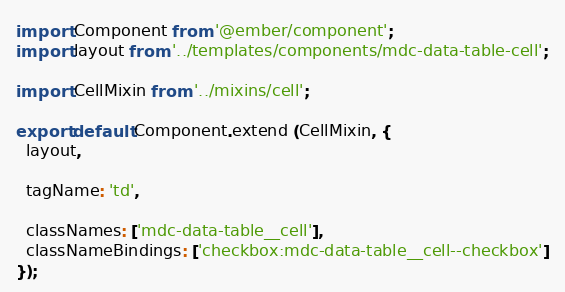Convert code to text. <code><loc_0><loc_0><loc_500><loc_500><_JavaScript_>import Component from '@ember/component';
import layout from '../templates/components/mdc-data-table-cell';

import CellMixin from '../mixins/cell';

export default Component.extend (CellMixin, {
  layout,

  tagName: 'td',

  classNames: ['mdc-data-table__cell'],
  classNameBindings: ['checkbox:mdc-data-table__cell--checkbox']
});
</code> 